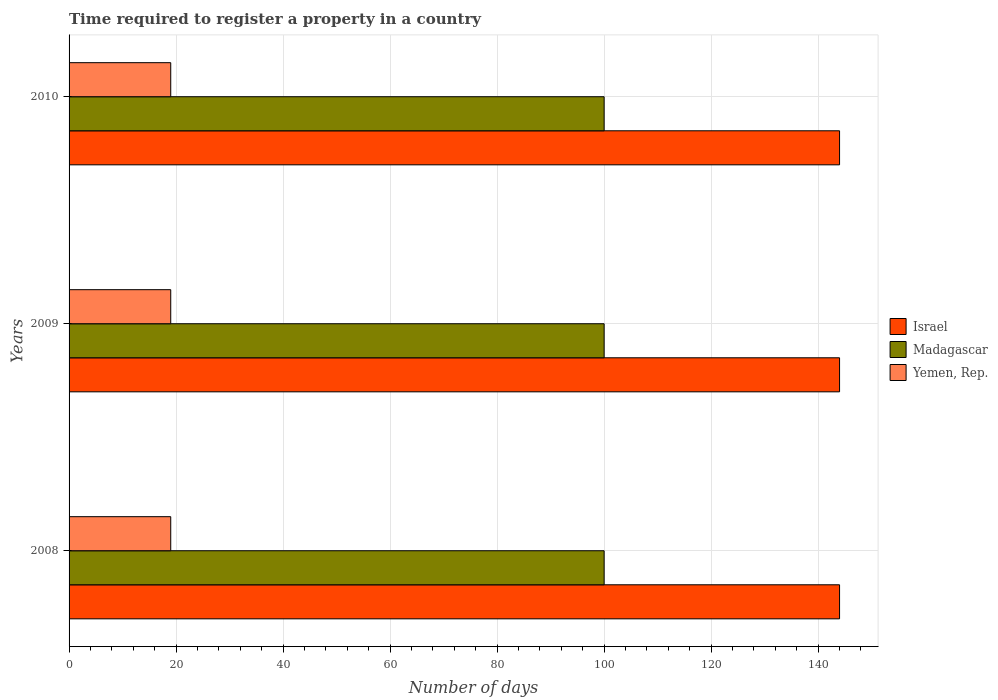How many different coloured bars are there?
Keep it short and to the point. 3. How many groups of bars are there?
Give a very brief answer. 3. Are the number of bars per tick equal to the number of legend labels?
Offer a very short reply. Yes. How many bars are there on the 1st tick from the bottom?
Provide a short and direct response. 3. What is the label of the 3rd group of bars from the top?
Ensure brevity in your answer.  2008. In how many cases, is the number of bars for a given year not equal to the number of legend labels?
Offer a terse response. 0. What is the number of days required to register a property in Madagascar in 2009?
Keep it short and to the point. 100. Across all years, what is the maximum number of days required to register a property in Yemen, Rep.?
Offer a terse response. 19. Across all years, what is the minimum number of days required to register a property in Madagascar?
Provide a short and direct response. 100. In which year was the number of days required to register a property in Madagascar maximum?
Provide a succinct answer. 2008. What is the total number of days required to register a property in Yemen, Rep. in the graph?
Your answer should be very brief. 57. What is the difference between the number of days required to register a property in Yemen, Rep. in 2008 and that in 2009?
Provide a succinct answer. 0. What is the difference between the number of days required to register a property in Madagascar in 2010 and the number of days required to register a property in Yemen, Rep. in 2008?
Make the answer very short. 81. What is the average number of days required to register a property in Yemen, Rep. per year?
Give a very brief answer. 19. In the year 2008, what is the difference between the number of days required to register a property in Israel and number of days required to register a property in Yemen, Rep.?
Provide a short and direct response. 125. In how many years, is the number of days required to register a property in Yemen, Rep. greater than 140 days?
Your answer should be compact. 0. What is the ratio of the number of days required to register a property in Yemen, Rep. in 2008 to that in 2010?
Your answer should be compact. 1. Is the difference between the number of days required to register a property in Israel in 2008 and 2009 greater than the difference between the number of days required to register a property in Yemen, Rep. in 2008 and 2009?
Offer a very short reply. No. What is the difference between the highest and the second highest number of days required to register a property in Madagascar?
Your answer should be very brief. 0. In how many years, is the number of days required to register a property in Yemen, Rep. greater than the average number of days required to register a property in Yemen, Rep. taken over all years?
Provide a succinct answer. 0. Is the sum of the number of days required to register a property in Yemen, Rep. in 2009 and 2010 greater than the maximum number of days required to register a property in Madagascar across all years?
Provide a short and direct response. No. What does the 2nd bar from the top in 2010 represents?
Your answer should be compact. Madagascar. What does the 3rd bar from the bottom in 2009 represents?
Offer a very short reply. Yemen, Rep. Is it the case that in every year, the sum of the number of days required to register a property in Israel and number of days required to register a property in Madagascar is greater than the number of days required to register a property in Yemen, Rep.?
Make the answer very short. Yes. Are all the bars in the graph horizontal?
Your answer should be compact. Yes. What is the difference between two consecutive major ticks on the X-axis?
Your answer should be very brief. 20. Does the graph contain grids?
Your response must be concise. Yes. How many legend labels are there?
Offer a terse response. 3. What is the title of the graph?
Your answer should be compact. Time required to register a property in a country. What is the label or title of the X-axis?
Your answer should be very brief. Number of days. What is the label or title of the Y-axis?
Ensure brevity in your answer.  Years. What is the Number of days in Israel in 2008?
Your answer should be very brief. 144. What is the Number of days in Madagascar in 2008?
Give a very brief answer. 100. What is the Number of days in Israel in 2009?
Provide a succinct answer. 144. What is the Number of days of Madagascar in 2009?
Provide a succinct answer. 100. What is the Number of days in Israel in 2010?
Provide a short and direct response. 144. What is the Number of days of Madagascar in 2010?
Give a very brief answer. 100. What is the Number of days in Yemen, Rep. in 2010?
Ensure brevity in your answer.  19. Across all years, what is the maximum Number of days in Israel?
Offer a terse response. 144. Across all years, what is the maximum Number of days in Madagascar?
Offer a very short reply. 100. Across all years, what is the maximum Number of days of Yemen, Rep.?
Provide a short and direct response. 19. Across all years, what is the minimum Number of days of Israel?
Provide a short and direct response. 144. Across all years, what is the minimum Number of days in Madagascar?
Provide a short and direct response. 100. Across all years, what is the minimum Number of days in Yemen, Rep.?
Offer a terse response. 19. What is the total Number of days of Israel in the graph?
Your answer should be very brief. 432. What is the total Number of days in Madagascar in the graph?
Your response must be concise. 300. What is the difference between the Number of days in Israel in 2008 and that in 2009?
Provide a short and direct response. 0. What is the difference between the Number of days of Madagascar in 2008 and that in 2009?
Your answer should be compact. 0. What is the difference between the Number of days of Yemen, Rep. in 2008 and that in 2009?
Your answer should be very brief. 0. What is the difference between the Number of days in Israel in 2008 and that in 2010?
Give a very brief answer. 0. What is the difference between the Number of days in Madagascar in 2008 and that in 2010?
Give a very brief answer. 0. What is the difference between the Number of days of Yemen, Rep. in 2008 and that in 2010?
Your response must be concise. 0. What is the difference between the Number of days of Israel in 2008 and the Number of days of Madagascar in 2009?
Your answer should be very brief. 44. What is the difference between the Number of days in Israel in 2008 and the Number of days in Yemen, Rep. in 2009?
Your answer should be compact. 125. What is the difference between the Number of days in Madagascar in 2008 and the Number of days in Yemen, Rep. in 2009?
Provide a short and direct response. 81. What is the difference between the Number of days in Israel in 2008 and the Number of days in Yemen, Rep. in 2010?
Offer a terse response. 125. What is the difference between the Number of days in Israel in 2009 and the Number of days in Madagascar in 2010?
Keep it short and to the point. 44. What is the difference between the Number of days in Israel in 2009 and the Number of days in Yemen, Rep. in 2010?
Offer a very short reply. 125. What is the difference between the Number of days in Madagascar in 2009 and the Number of days in Yemen, Rep. in 2010?
Your answer should be compact. 81. What is the average Number of days in Israel per year?
Offer a very short reply. 144. What is the average Number of days of Madagascar per year?
Ensure brevity in your answer.  100. In the year 2008, what is the difference between the Number of days in Israel and Number of days in Yemen, Rep.?
Provide a succinct answer. 125. In the year 2009, what is the difference between the Number of days of Israel and Number of days of Madagascar?
Offer a very short reply. 44. In the year 2009, what is the difference between the Number of days in Israel and Number of days in Yemen, Rep.?
Your response must be concise. 125. In the year 2010, what is the difference between the Number of days of Israel and Number of days of Madagascar?
Offer a very short reply. 44. In the year 2010, what is the difference between the Number of days in Israel and Number of days in Yemen, Rep.?
Make the answer very short. 125. What is the ratio of the Number of days in Israel in 2008 to that in 2009?
Provide a succinct answer. 1. What is the ratio of the Number of days of Madagascar in 2008 to that in 2009?
Your answer should be compact. 1. What is the ratio of the Number of days in Yemen, Rep. in 2008 to that in 2009?
Your response must be concise. 1. What is the ratio of the Number of days in Yemen, Rep. in 2008 to that in 2010?
Your response must be concise. 1. What is the difference between the highest and the second highest Number of days in Israel?
Give a very brief answer. 0. What is the difference between the highest and the second highest Number of days of Madagascar?
Your response must be concise. 0. What is the difference between the highest and the second highest Number of days in Yemen, Rep.?
Ensure brevity in your answer.  0. What is the difference between the highest and the lowest Number of days in Madagascar?
Provide a succinct answer. 0. What is the difference between the highest and the lowest Number of days of Yemen, Rep.?
Give a very brief answer. 0. 